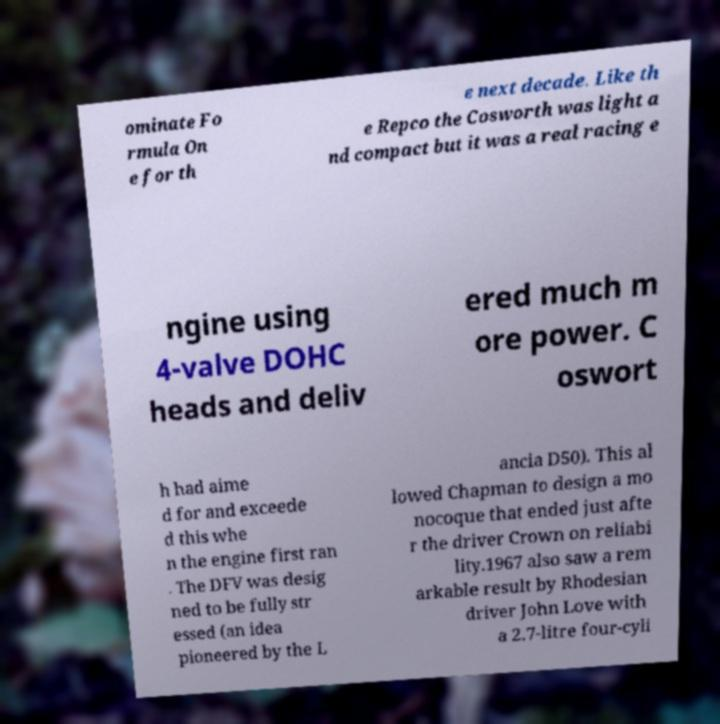There's text embedded in this image that I need extracted. Can you transcribe it verbatim? ominate Fo rmula On e for th e next decade. Like th e Repco the Cosworth was light a nd compact but it was a real racing e ngine using 4-valve DOHC heads and deliv ered much m ore power. C oswort h had aime d for and exceede d this whe n the engine first ran . The DFV was desig ned to be fully str essed (an idea pioneered by the L ancia D50). This al lowed Chapman to design a mo nocoque that ended just afte r the driver Crown on reliabi lity.1967 also saw a rem arkable result by Rhodesian driver John Love with a 2.7-litre four-cyli 